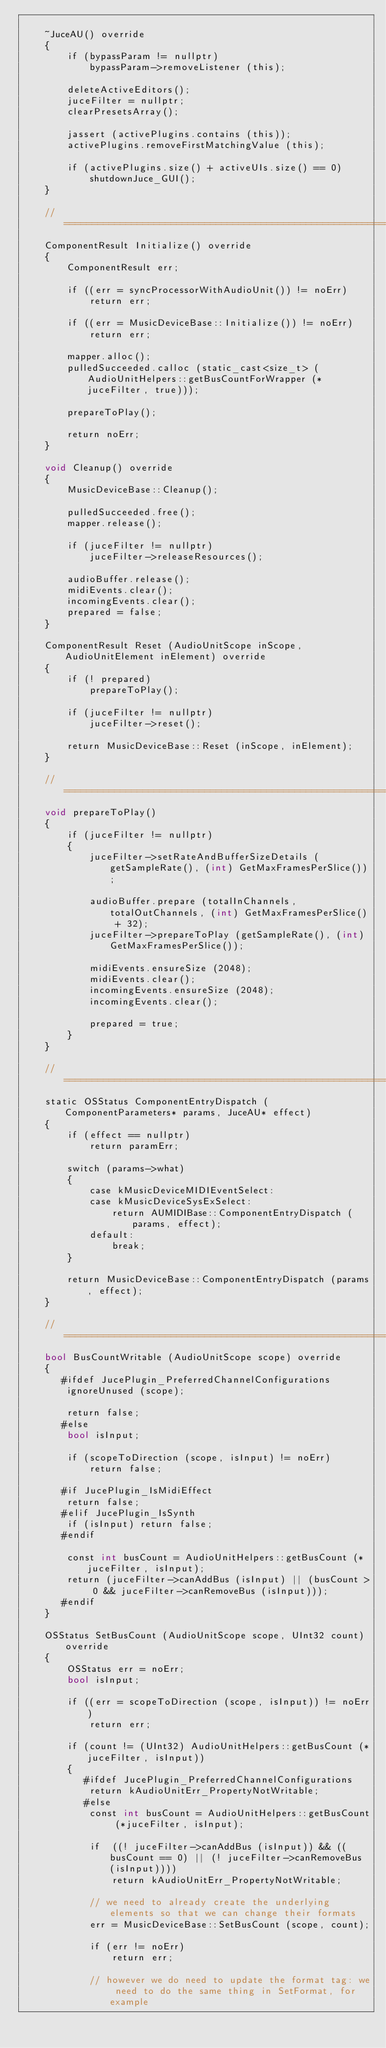Convert code to text. <code><loc_0><loc_0><loc_500><loc_500><_ObjectiveC_>
    ~JuceAU() override
    {
        if (bypassParam != nullptr)
            bypassParam->removeListener (this);

        deleteActiveEditors();
        juceFilter = nullptr;
        clearPresetsArray();

        jassert (activePlugins.contains (this));
        activePlugins.removeFirstMatchingValue (this);

        if (activePlugins.size() + activeUIs.size() == 0)
            shutdownJuce_GUI();
    }

    //==============================================================================
    ComponentResult Initialize() override
    {
        ComponentResult err;

        if ((err = syncProcessorWithAudioUnit()) != noErr)
            return err;

        if ((err = MusicDeviceBase::Initialize()) != noErr)
            return err;

        mapper.alloc();
        pulledSucceeded.calloc (static_cast<size_t> (AudioUnitHelpers::getBusCountForWrapper (*juceFilter, true)));

        prepareToPlay();

        return noErr;
    }

    void Cleanup() override
    {
        MusicDeviceBase::Cleanup();

        pulledSucceeded.free();
        mapper.release();

        if (juceFilter != nullptr)
            juceFilter->releaseResources();

        audioBuffer.release();
        midiEvents.clear();
        incomingEvents.clear();
        prepared = false;
    }

    ComponentResult Reset (AudioUnitScope inScope, AudioUnitElement inElement) override
    {
        if (! prepared)
            prepareToPlay();

        if (juceFilter != nullptr)
            juceFilter->reset();

        return MusicDeviceBase::Reset (inScope, inElement);
    }

    //==============================================================================
    void prepareToPlay()
    {
        if (juceFilter != nullptr)
        {
            juceFilter->setRateAndBufferSizeDetails (getSampleRate(), (int) GetMaxFramesPerSlice());

            audioBuffer.prepare (totalInChannels, totalOutChannels, (int) GetMaxFramesPerSlice() + 32);
            juceFilter->prepareToPlay (getSampleRate(), (int) GetMaxFramesPerSlice());

            midiEvents.ensureSize (2048);
            midiEvents.clear();
            incomingEvents.ensureSize (2048);
            incomingEvents.clear();

            prepared = true;
        }
    }

    //==============================================================================
    static OSStatus ComponentEntryDispatch (ComponentParameters* params, JuceAU* effect)
    {
        if (effect == nullptr)
            return paramErr;

        switch (params->what)
        {
            case kMusicDeviceMIDIEventSelect:
            case kMusicDeviceSysExSelect:
                return AUMIDIBase::ComponentEntryDispatch (params, effect);
            default:
                break;
        }

        return MusicDeviceBase::ComponentEntryDispatch (params, effect);
    }

    //==============================================================================
    bool BusCountWritable (AudioUnitScope scope) override
    {
       #ifdef JucePlugin_PreferredChannelConfigurations
        ignoreUnused (scope);

        return false;
       #else
        bool isInput;

        if (scopeToDirection (scope, isInput) != noErr)
            return false;

       #if JucePlugin_IsMidiEffect
        return false;
       #elif JucePlugin_IsSynth
        if (isInput) return false;
       #endif

        const int busCount = AudioUnitHelpers::getBusCount (*juceFilter, isInput);
        return (juceFilter->canAddBus (isInput) || (busCount > 0 && juceFilter->canRemoveBus (isInput)));
       #endif
    }

    OSStatus SetBusCount (AudioUnitScope scope, UInt32 count) override
    {
        OSStatus err = noErr;
        bool isInput;

        if ((err = scopeToDirection (scope, isInput)) != noErr)
            return err;

        if (count != (UInt32) AudioUnitHelpers::getBusCount (*juceFilter, isInput))
        {
           #ifdef JucePlugin_PreferredChannelConfigurations
            return kAudioUnitErr_PropertyNotWritable;
           #else
            const int busCount = AudioUnitHelpers::getBusCount (*juceFilter, isInput);

            if  ((! juceFilter->canAddBus (isInput)) && ((busCount == 0) || (! juceFilter->canRemoveBus (isInput))))
                return kAudioUnitErr_PropertyNotWritable;

            // we need to already create the underlying elements so that we can change their formats
            err = MusicDeviceBase::SetBusCount (scope, count);

            if (err != noErr)
                return err;

            // however we do need to update the format tag: we need to do the same thing in SetFormat, for example</code> 